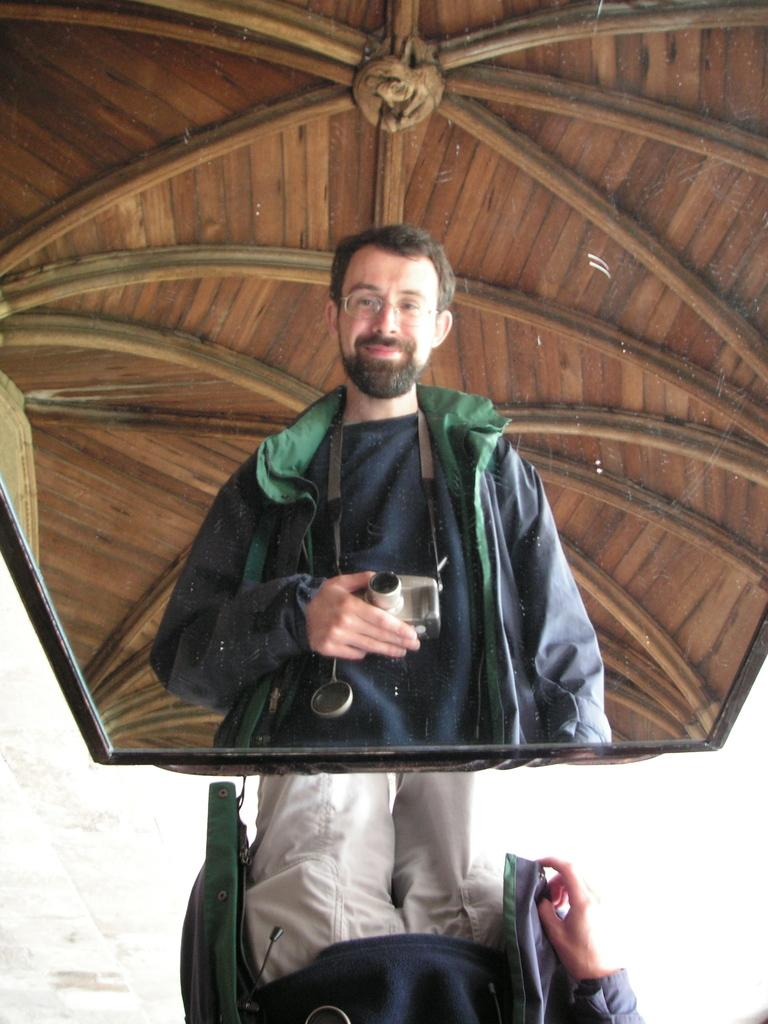What object is present in the image that can show reflections? There is a mirror in the image. What can be seen in the mirror's reflection? The reflection of a person is visible in the mirror. What is the person holding in the image? The person is holding a camera. What type of trousers is the beginner wearing in the image? There is no information about the person's trousers or their level of expertise in the image. 